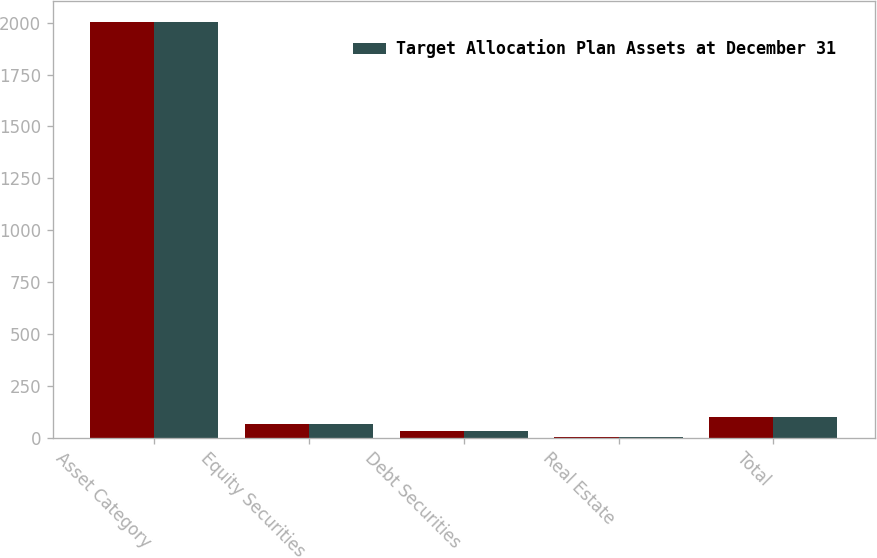<chart> <loc_0><loc_0><loc_500><loc_500><stacked_bar_chart><ecel><fcel>Asset Category<fcel>Equity Securities<fcel>Debt Securities<fcel>Real Estate<fcel>Total<nl><fcel>nan<fcel>2004<fcel>65<fcel>30<fcel>5<fcel>100<nl><fcel>Target Allocation Plan Assets at December 31<fcel>2003<fcel>64<fcel>32<fcel>4<fcel>100<nl></chart> 